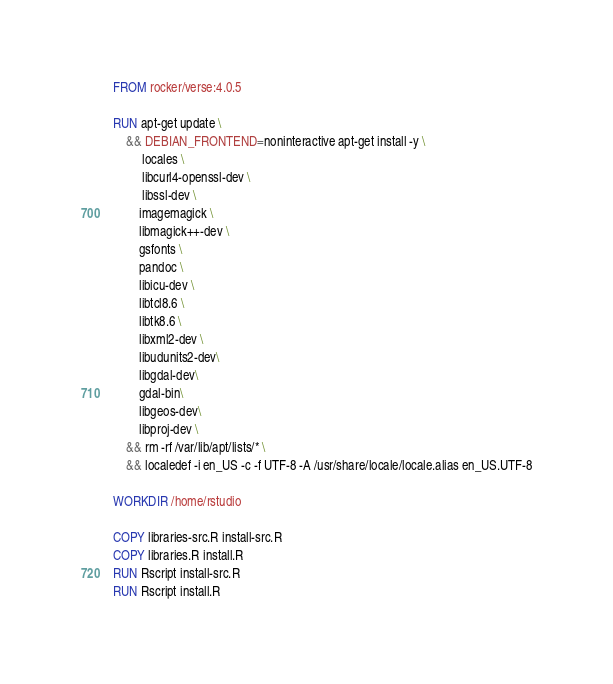<code> <loc_0><loc_0><loc_500><loc_500><_Dockerfile_>FROM rocker/verse:4.0.5

RUN apt-get update \
    && DEBIAN_FRONTEND=noninteractive apt-get install -y \
         locales \
         libcurl4-openssl-dev \
         libssl-dev \
        imagemagick \
        libmagick++-dev \
        gsfonts \
        pandoc \
        libicu-dev \
        libtcl8.6 \
        libtk8.6 \
        libxml2-dev \
        libudunits2-dev\
        libgdal-dev\
        gdal-bin\
        libgeos-dev\
        libproj-dev \
    && rm -rf /var/lib/apt/lists/* \
    && localedef -i en_US -c -f UTF-8 -A /usr/share/locale/locale.alias en_US.UTF-8

WORKDIR /home/rstudio

COPY libraries-src.R install-src.R
COPY libraries.R install.R
RUN Rscript install-src.R
RUN Rscript install.R


</code> 